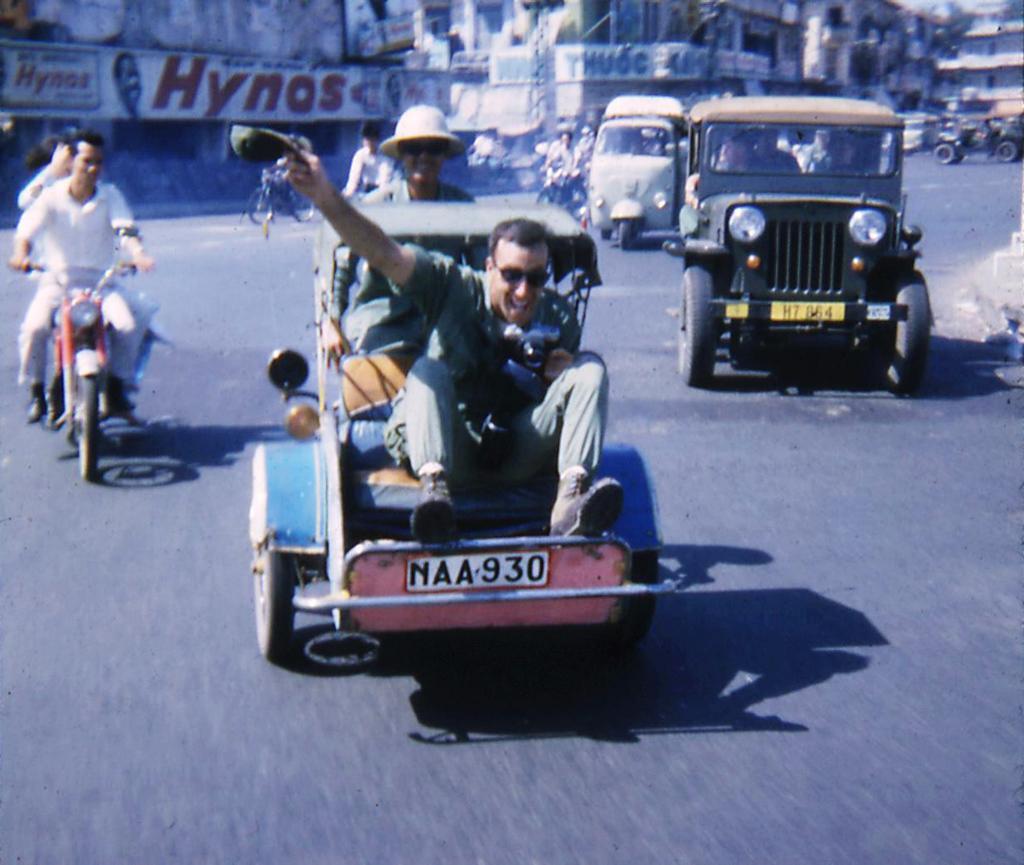In one or two sentences, can you explain what this image depicts? This person is riding a motorbike. A vehicles on road. This person is sitting on this vehicle. These are buildings. On this buildings there are boards. This two persons holds a smile and wore goggles. 